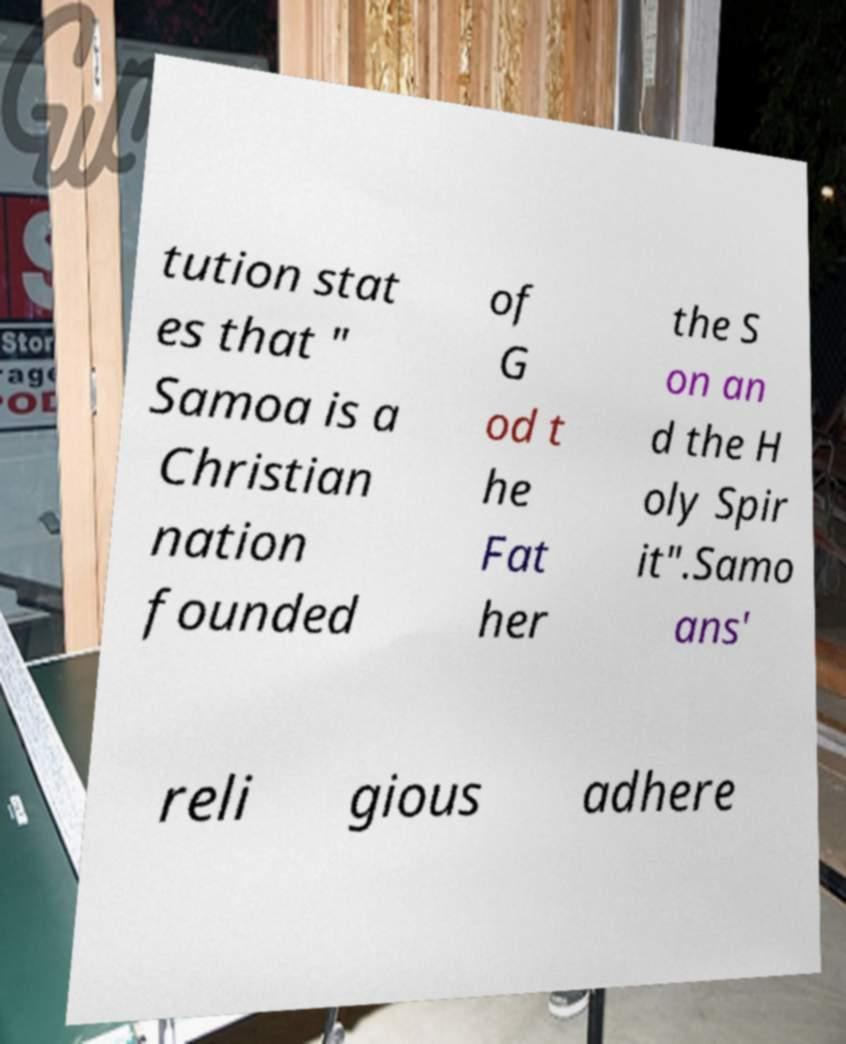Can you accurately transcribe the text from the provided image for me? tution stat es that " Samoa is a Christian nation founded of G od t he Fat her the S on an d the H oly Spir it".Samo ans' reli gious adhere 